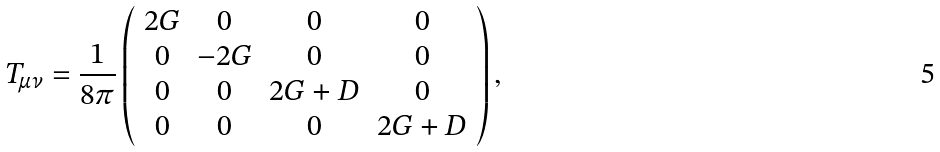Convert formula to latex. <formula><loc_0><loc_0><loc_500><loc_500>T _ { \mu \nu } = \frac { 1 } { 8 \pi } \left ( \begin{array} { c c c c } 2 G & 0 & 0 & 0 \\ 0 & - 2 G & 0 & 0 \\ 0 & 0 & 2 G + D & 0 \\ 0 & 0 & 0 & 2 G + D \end{array} \right ) ,</formula> 